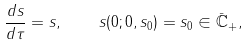<formula> <loc_0><loc_0><loc_500><loc_500>\frac { d s } { d \tau } = s , \quad s ( 0 ; 0 , s _ { 0 } ) = s _ { 0 } \in \bar { \mathbb { C } } _ { + } ,</formula> 